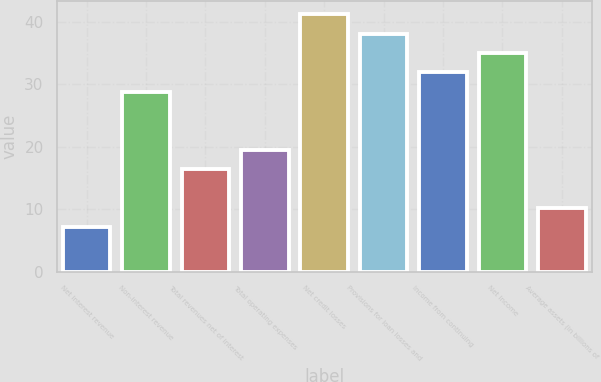Convert chart to OTSL. <chart><loc_0><loc_0><loc_500><loc_500><bar_chart><fcel>Net interest revenue<fcel>Non-interest revenue<fcel>Total revenues net of interest<fcel>Total operating expenses<fcel>Net credit losses<fcel>Provisions for loan losses and<fcel>Income from continuing<fcel>Net income<fcel>Average assets (in billions of<nl><fcel>7.1<fcel>28.8<fcel>16.4<fcel>19.5<fcel>41.2<fcel>38.1<fcel>31.9<fcel>35<fcel>10.2<nl></chart> 